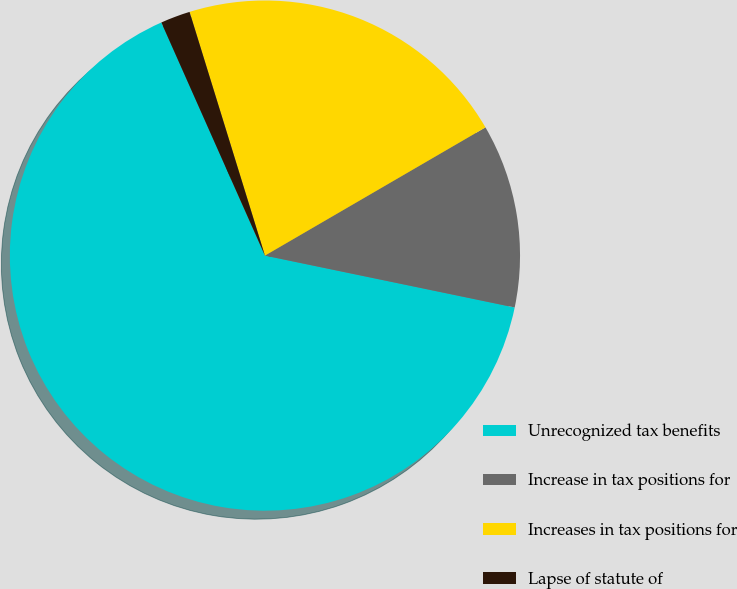<chart> <loc_0><loc_0><loc_500><loc_500><pie_chart><fcel>Unrecognized tax benefits<fcel>Increase in tax positions for<fcel>Increases in tax positions for<fcel>Lapse of statute of<nl><fcel>65.08%<fcel>11.64%<fcel>21.39%<fcel>1.88%<nl></chart> 